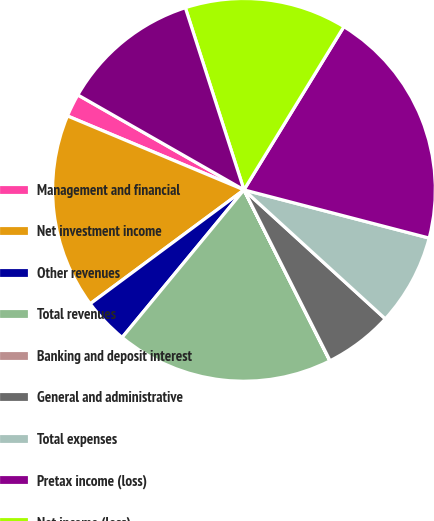Convert chart to OTSL. <chart><loc_0><loc_0><loc_500><loc_500><pie_chart><fcel>Management and financial<fcel>Net investment income<fcel>Other revenues<fcel>Total revenues<fcel>Banking and deposit interest<fcel>General and administrative<fcel>Total expenses<fcel>Pretax income (loss)<fcel>Net income (loss)<fcel>Net income (loss) attributable<nl><fcel>1.95%<fcel>16.46%<fcel>3.87%<fcel>18.39%<fcel>0.02%<fcel>5.8%<fcel>7.72%<fcel>20.31%<fcel>13.7%<fcel>11.78%<nl></chart> 